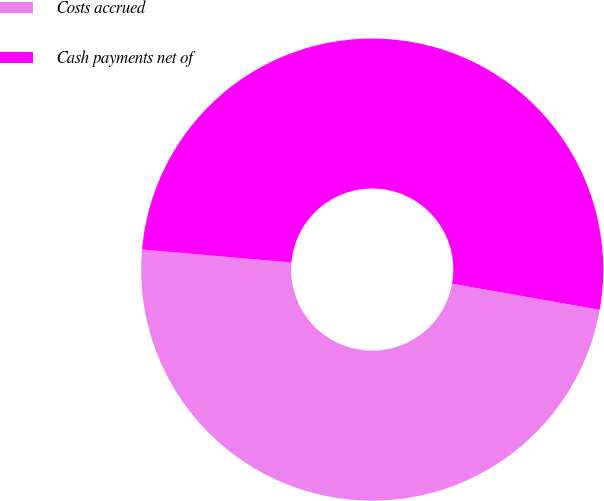<chart> <loc_0><loc_0><loc_500><loc_500><pie_chart><fcel>Costs accrued<fcel>Cash payments net of<nl><fcel>48.6%<fcel>51.4%<nl></chart> 